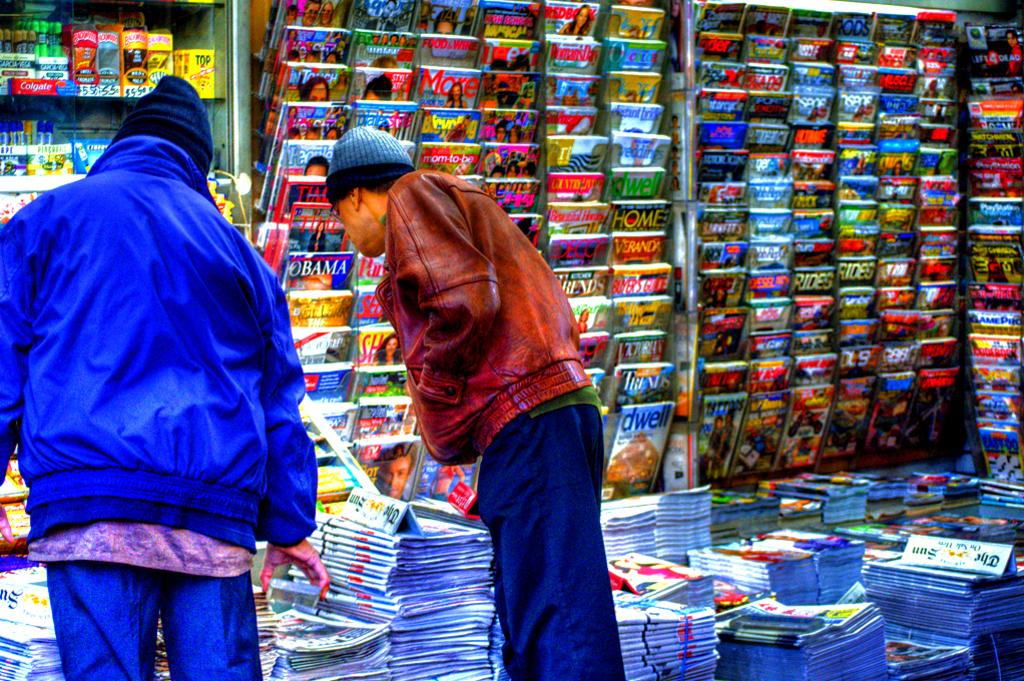<image>
Give a short and clear explanation of the subsequent image. A newspaper stand with two customers browsing, the Sun is a newspaper that is for sale. 